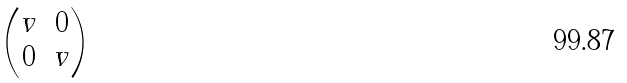<formula> <loc_0><loc_0><loc_500><loc_500>\begin{pmatrix} v & 0 \\ 0 & v \end{pmatrix}</formula> 